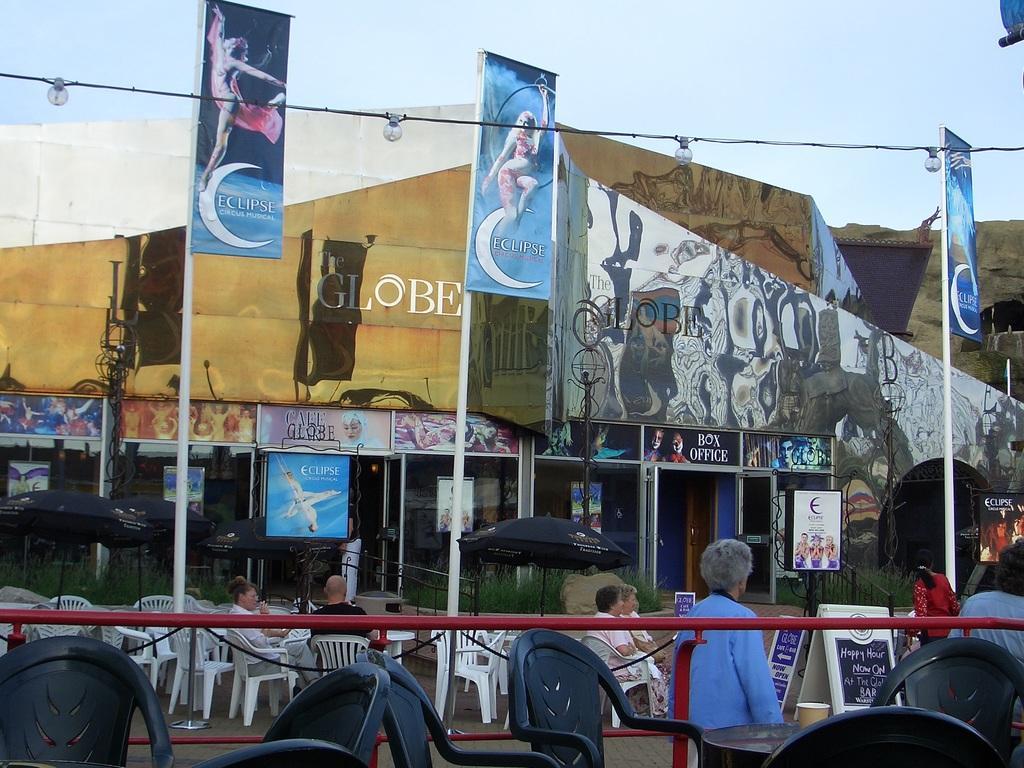Can you describe this image briefly? In this image in the front there are empty chairs. In the center there is a railing which is red in colour and there are persons sitting on the chair and there is an umbrella which is black in colour, there are poles, flags. In the background there is a building and on the building there is some text written on it. 